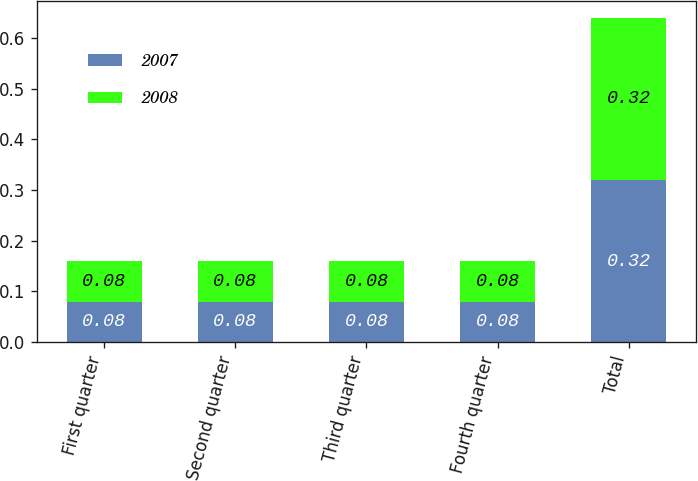Convert chart to OTSL. <chart><loc_0><loc_0><loc_500><loc_500><stacked_bar_chart><ecel><fcel>First quarter<fcel>Second quarter<fcel>Third quarter<fcel>Fourth quarter<fcel>Total<nl><fcel>2007<fcel>0.08<fcel>0.08<fcel>0.08<fcel>0.08<fcel>0.32<nl><fcel>2008<fcel>0.08<fcel>0.08<fcel>0.08<fcel>0.08<fcel>0.32<nl></chart> 